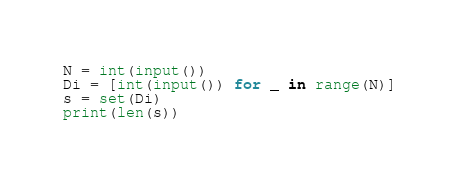Convert code to text. <code><loc_0><loc_0><loc_500><loc_500><_Python_>N = int(input())
Di = [int(input()) for _ in range(N)]
s = set(Di)
print(len(s))</code> 